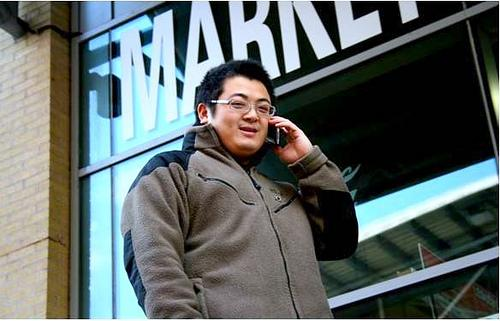Estimate how many objects are present in the scene. There are approximately 20 identifiable objects in the scene. Based on his appearance and actions, what might be the man's occupation or role? The man could be a businessman or an office worker taking a call during a break. Identify the primary action of the man in the image. The man is talking on a cell phone. Are there any markings or signs visible in the image? Describe them. A white letter 'M' and a market sign on the wall are visible in the image. Characterize the emotion the image portrays. The image portrays a casual and focused emotion, as the man is engaged in a phone conversation. Briefly describe the appearance of the man's jacket. The man is wearing a brown and black coat with black patches on elbows and angled zipper. Determine the hair color of the man in the image. The man has black hair. Is the man indoors or outdoors, and what can you see behind him? The man is outdoors, standing in front of a brown brick wall and a large window in a building. What type of eyewear does the man have on? The man is wearing white glasses. Analyze the interaction of the cell phone with the man's hand. The man is holding the cell phone to his ear with one hand, making physical contact. Describe the appearance of the market sign. The market sign is white in color. Is there anything unusual or out of place in this image? No, there are no anomalies detected. Does the dog sitting near the building have a brown collar? It's interesting how the dog's collar matches the wall's color. Does the man in the image wear glasses? Yes, the man is wearing glasses. How is the man interacting with the cell phone? The man is holding the cell phone to his ear. Identify the color of the man's glasses. The glasses are clear. Identify the material of the building's exterior. The wall is made of brick. Point out the sentence that describes the man's coat most accurately. A man wearing brown and black coat. Describe the interaction between the man and the building. A man standing in front of a building. Can you spot the blue car parked behind the man? The color of the car is so bright, it caught my attention right away. Do you notice children playing in the distance across the street? The laughter of the children brings life to the otherwise mundane scenery. Evaluate the quality of this image. The image quality is sharp and clear. Which of the following can be inferred from the image: a) the man is indoors, b) the man is outdoors, c) the location is uncertain? b) the man is outdoors. Identify the main object in the image. A man using a cell phone. What is the man doing in this picture? The man is talking on his cell phone. Identify any text in the image. A white letter 'm'. How many zippers are on the man's jacket? Two zippers. Find the coordinates of the man's black hair in the image. X: 206, Y: 75, Width: 10, Height: 10 List three attributes of the man's jacket. Brown and black color, zipper on the front, black patches on elbows. Explain the scene's setting. The scene is outdoors, with a man standing in front of a building. What pattern is on the wall? A brick pattern. Select the right description for the man's hair color. The hair is black. Can you see the green bicycle leaning against the wall? The bicycle seems to be well-maintained and ready for a ride. Is the woman next to the man wearing a red hat? I really like how the lady's red hat complements her outfit. What is the shape of the glasses? The glasses are rectangular. Is the tall tree in the background touching the top of the building? The presence of the tree enhances the overall appeal of the scene. 